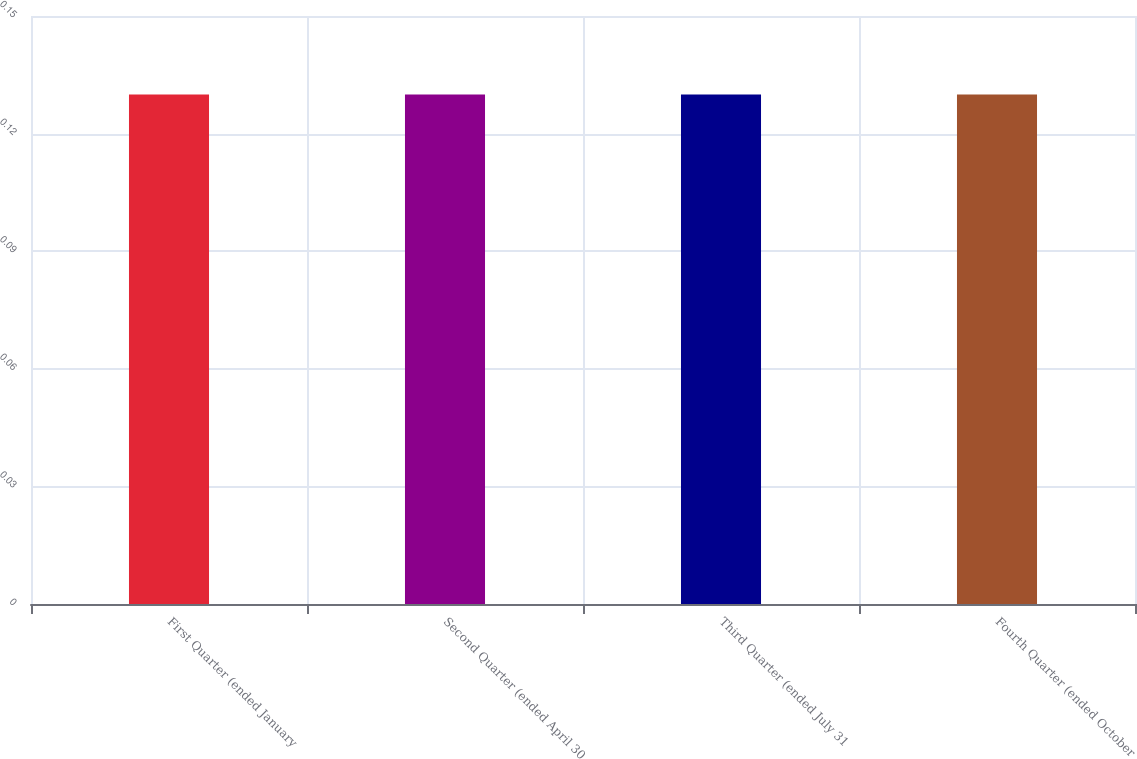<chart> <loc_0><loc_0><loc_500><loc_500><bar_chart><fcel>First Quarter (ended January<fcel>Second Quarter (ended April 30<fcel>Third Quarter (ended July 31<fcel>Fourth Quarter (ended October<nl><fcel>0.13<fcel>0.13<fcel>0.13<fcel>0.13<nl></chart> 